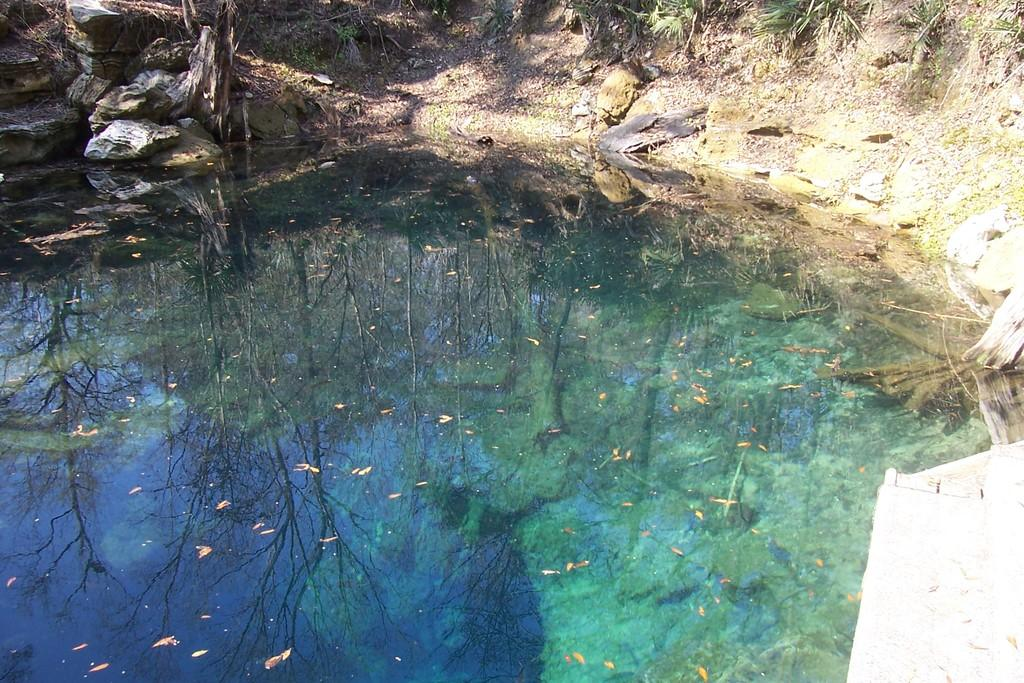What type of body of water is present in the image? There is a lake in the image. What can be seen in the lake? The shadow of trees is visible in the lake. What part of the natural environment is visible in the image? The sky is visible in the image. Where are the stones located in the image? The stones are in the top left of the image. What type of wilderness is depicted in the image? The image does not depict a specific type of wilderness; it simply shows a lake with tree shadows and stones. Is there a scarecrow visible in the image? There is no scarecrow present in the image. 